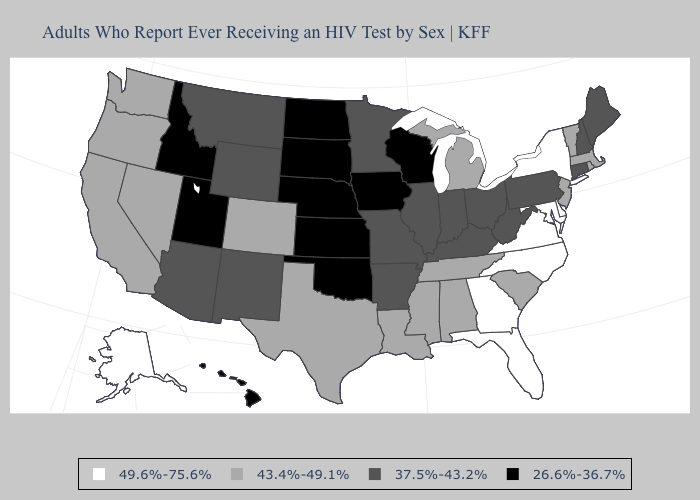Which states hav the highest value in the MidWest?
Be succinct. Michigan. Name the states that have a value in the range 37.5%-43.2%?
Answer briefly. Arizona, Arkansas, Connecticut, Illinois, Indiana, Kentucky, Maine, Minnesota, Missouri, Montana, New Hampshire, New Mexico, Ohio, Pennsylvania, West Virginia, Wyoming. Does the first symbol in the legend represent the smallest category?
Answer briefly. No. What is the value of Georgia?
Give a very brief answer. 49.6%-75.6%. What is the highest value in the MidWest ?
Give a very brief answer. 43.4%-49.1%. What is the highest value in states that border Vermont?
Write a very short answer. 49.6%-75.6%. What is the value of New Mexico?
Answer briefly. 37.5%-43.2%. What is the lowest value in the South?
Concise answer only. 26.6%-36.7%. What is the value of West Virginia?
Be succinct. 37.5%-43.2%. Which states have the lowest value in the USA?
Keep it brief. Hawaii, Idaho, Iowa, Kansas, Nebraska, North Dakota, Oklahoma, South Dakota, Utah, Wisconsin. What is the highest value in the USA?
Answer briefly. 49.6%-75.6%. What is the lowest value in states that border Massachusetts?
Be succinct. 37.5%-43.2%. Which states have the lowest value in the MidWest?
Keep it brief. Iowa, Kansas, Nebraska, North Dakota, South Dakota, Wisconsin. What is the value of Hawaii?
Keep it brief. 26.6%-36.7%. Is the legend a continuous bar?
Short answer required. No. 